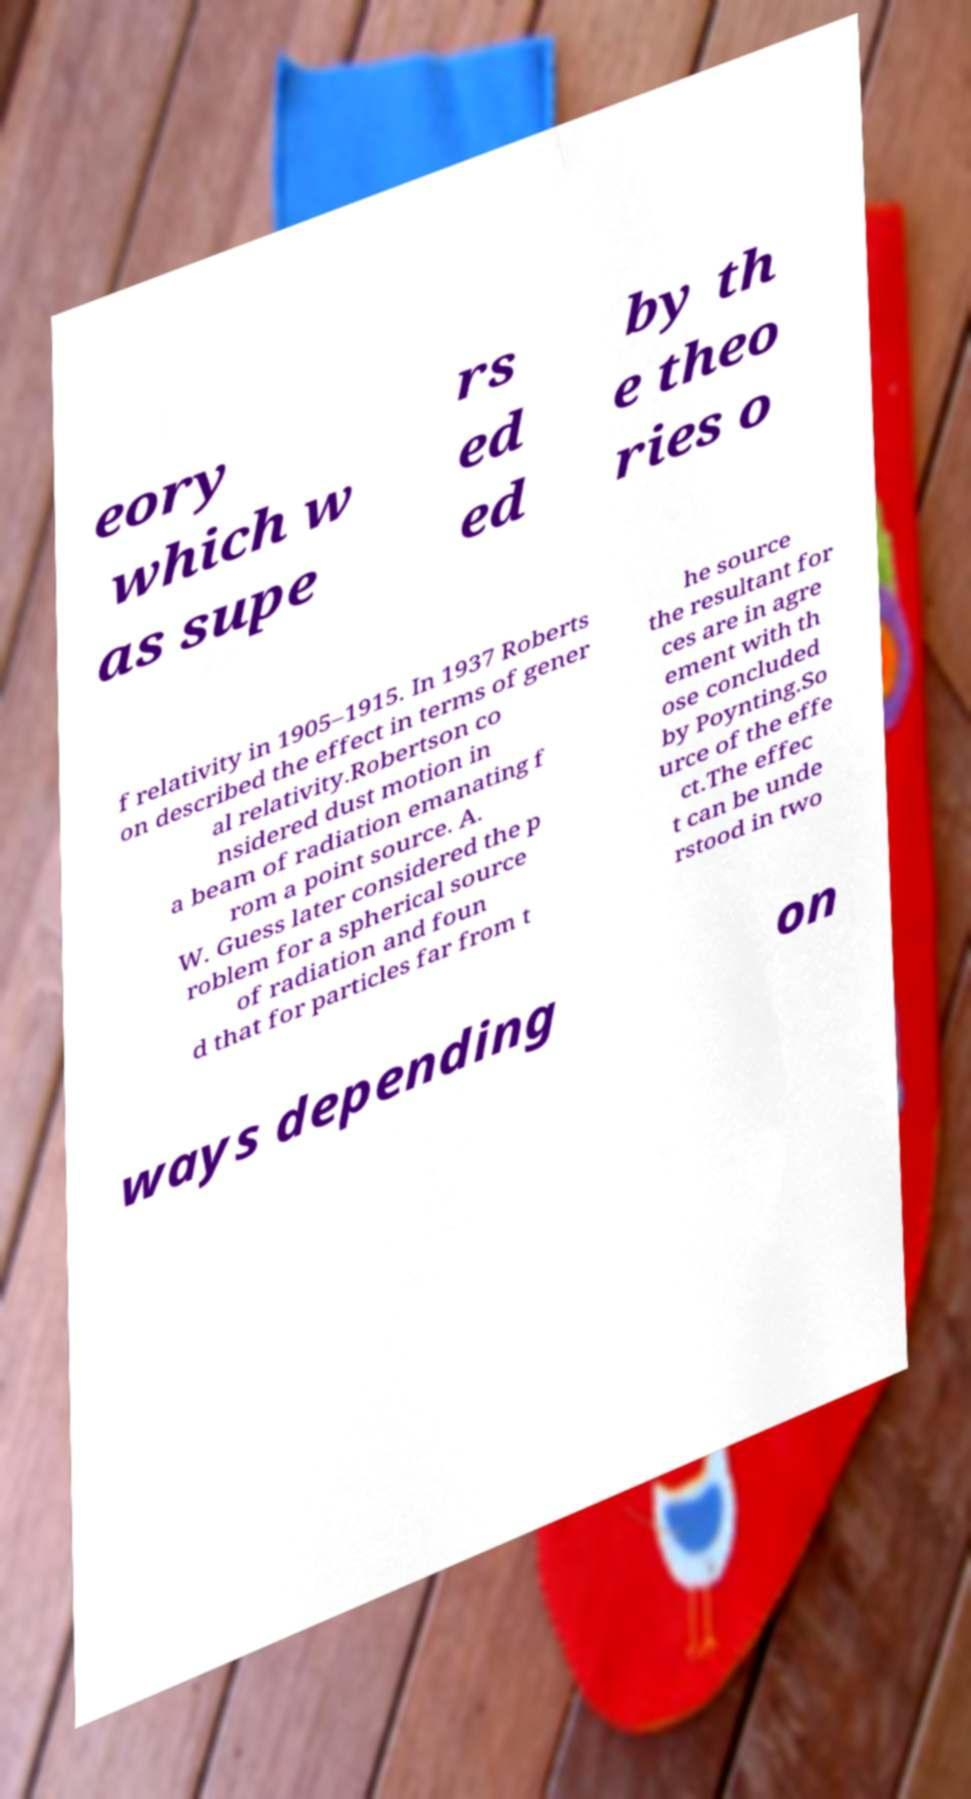Please read and relay the text visible in this image. What does it say? eory which w as supe rs ed ed by th e theo ries o f relativity in 1905–1915. In 1937 Roberts on described the effect in terms of gener al relativity.Robertson co nsidered dust motion in a beam of radiation emanating f rom a point source. A. W. Guess later considered the p roblem for a spherical source of radiation and foun d that for particles far from t he source the resultant for ces are in agre ement with th ose concluded by Poynting.So urce of the effe ct.The effec t can be unde rstood in two ways depending on 